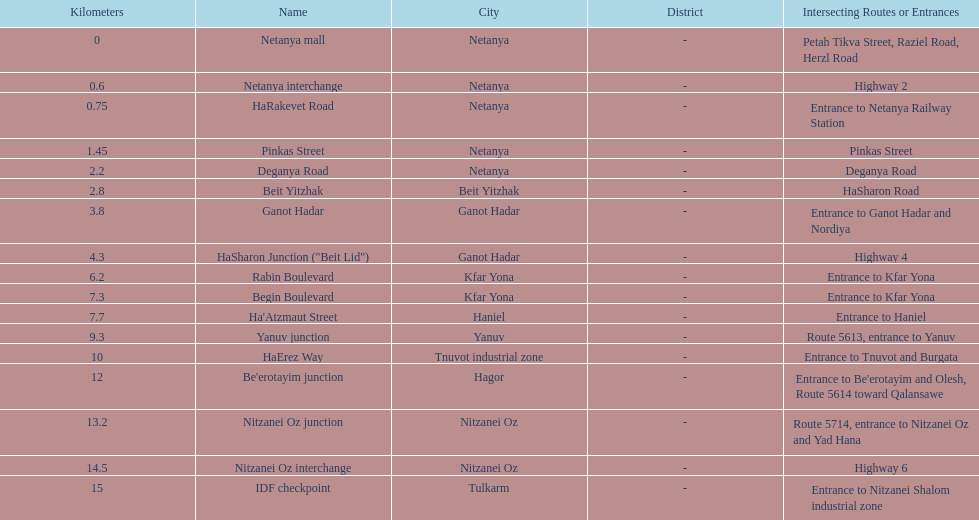How many sections intersect highway 2? 1. 